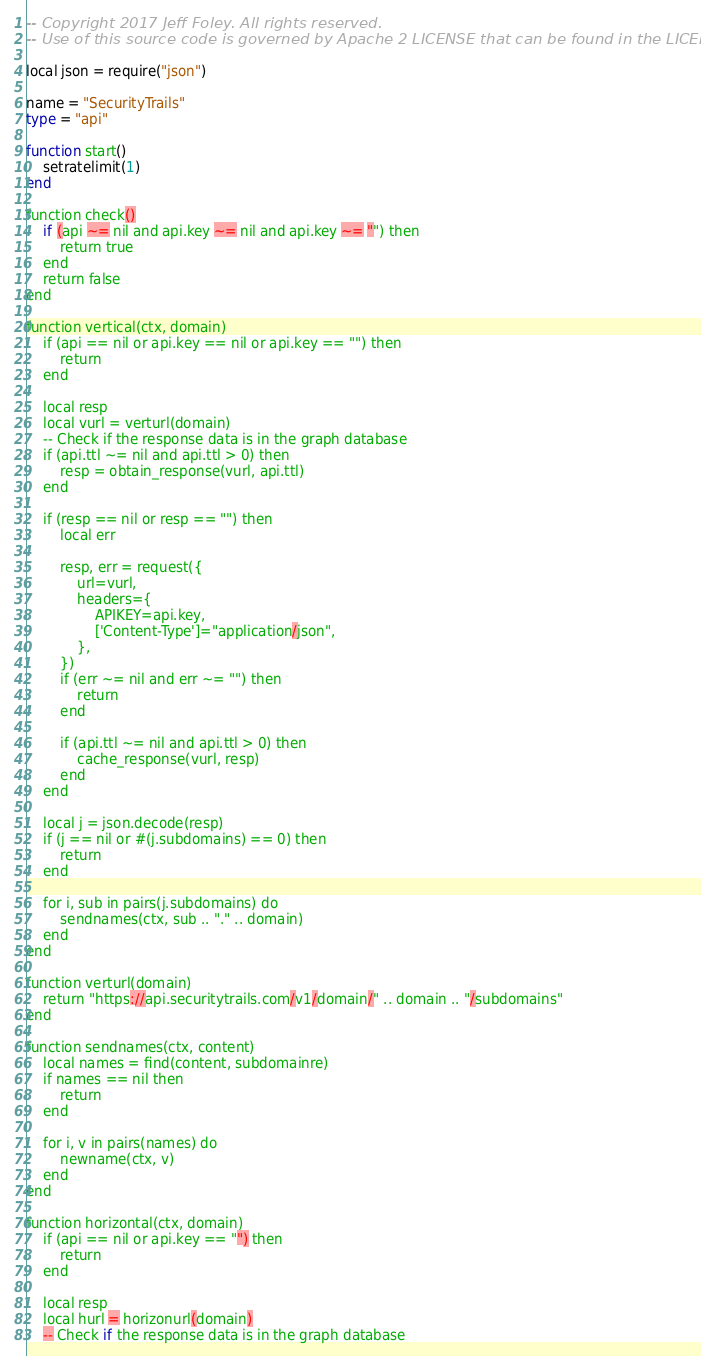Convert code to text. <code><loc_0><loc_0><loc_500><loc_500><_Ada_>-- Copyright 2017 Jeff Foley. All rights reserved.
-- Use of this source code is governed by Apache 2 LICENSE that can be found in the LICENSE file.

local json = require("json")

name = "SecurityTrails"
type = "api"

function start()
    setratelimit(1)
end

function check()
    if (api ~= nil and api.key ~= nil and api.key ~= "") then
        return true
    end
    return false
end

function vertical(ctx, domain)
    if (api == nil or api.key == nil or api.key == "") then
        return
    end

    local resp
    local vurl = verturl(domain)
    -- Check if the response data is in the graph database
    if (api.ttl ~= nil and api.ttl > 0) then
        resp = obtain_response(vurl, api.ttl)
    end

    if (resp == nil or resp == "") then
        local err

        resp, err = request({
            url=vurl,
            headers={
                APIKEY=api.key,
                ['Content-Type']="application/json",
            },
        })
        if (err ~= nil and err ~= "") then
            return
        end

        if (api.ttl ~= nil and api.ttl > 0) then
            cache_response(vurl, resp)
        end
    end

    local j = json.decode(resp)
    if (j == nil or #(j.subdomains) == 0) then
        return
    end

    for i, sub in pairs(j.subdomains) do
        sendnames(ctx, sub .. "." .. domain)
    end
end

function verturl(domain)
    return "https://api.securitytrails.com/v1/domain/" .. domain .. "/subdomains"
end

function sendnames(ctx, content)
    local names = find(content, subdomainre)
    if names == nil then
        return
    end

    for i, v in pairs(names) do
        newname(ctx, v)
    end
end

function horizontal(ctx, domain)
    if (api == nil or api.key == "") then
        return
    end

    local resp
    local hurl = horizonurl(domain)
    -- Check if the response data is in the graph database</code> 